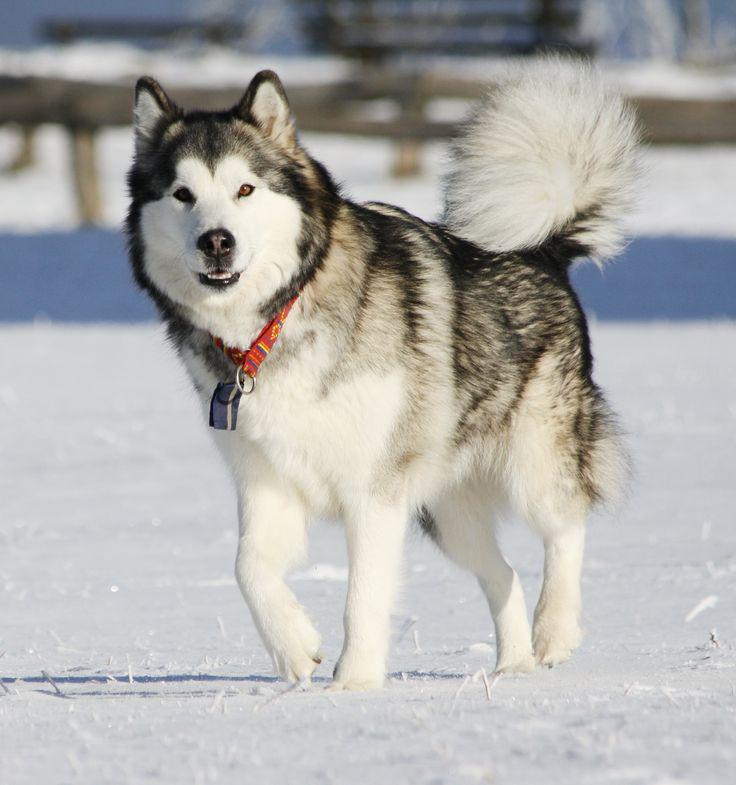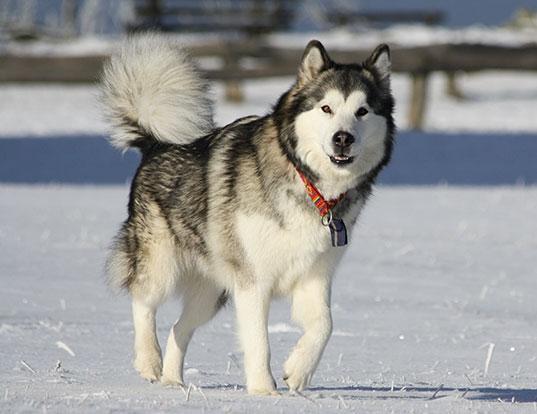The first image is the image on the left, the second image is the image on the right. Given the left and right images, does the statement "There are three dogs." hold true? Answer yes or no. No. The first image is the image on the left, the second image is the image on the right. Evaluate the accuracy of this statement regarding the images: "The left and right image contains the same number of dogs.". Is it true? Answer yes or no. Yes. 